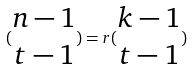<formula> <loc_0><loc_0><loc_500><loc_500>( \begin{matrix} n - 1 \\ t - 1 \end{matrix} ) = r ( \begin{matrix} k - 1 \\ t - 1 \end{matrix} )</formula> 